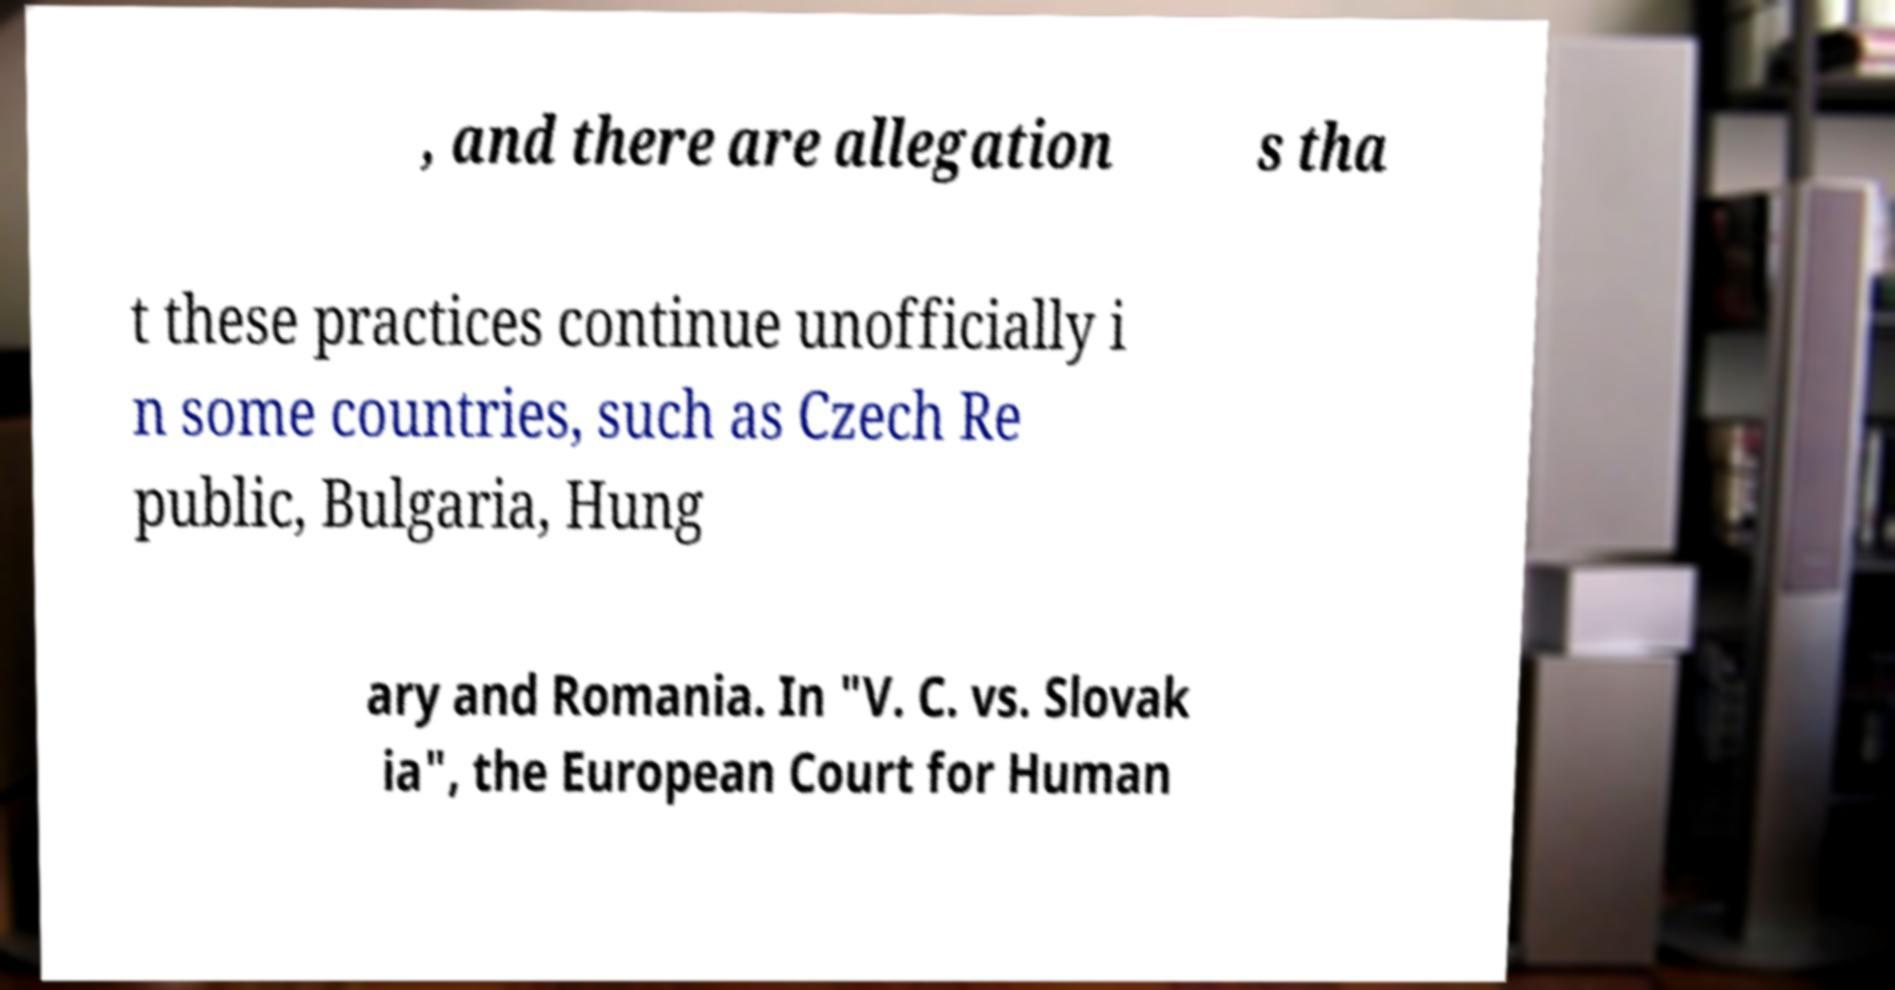Could you extract and type out the text from this image? , and there are allegation s tha t these practices continue unofficially i n some countries, such as Czech Re public, Bulgaria, Hung ary and Romania. In "V. C. vs. Slovak ia", the European Court for Human 